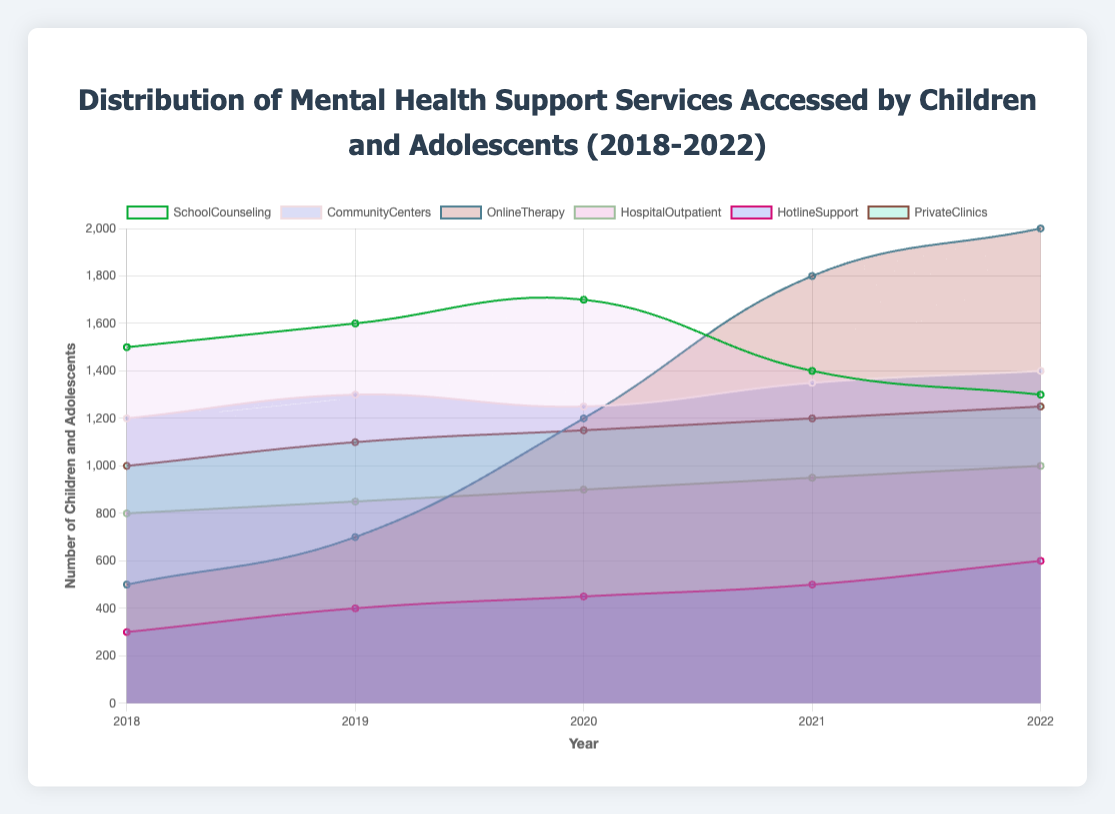What service had the highest access in 2022? The figure shows the values for each service in 2022. The tallest section for that year indicates the service with the highest access.
Answer: OnlineTherapy Which service showed a consistent increase over the five years? Observing the trend lines for each service, we see that OnlineTherapy consistently rises from 2018 to 2022.
Answer: OnlineTherapy How does the trend for School Counseling from 2018 to 2022 compare to Community Centers? From 2018 to 2022, School Counseling initially increases but then decreases, while Community Centers show a gradual increase.
Answer: SchoolCounseling drops while CommunityCenters rises What is the total number of children and adolescents accessing Hospital Outpatient services over 5 years? Summing the given values for Hospital Outpatient (800 + 850 + 900 + 950 + 1000) results in the total access over 5 years.
Answer: 4500 Which year had the highest total number of children accessing all services combined? To find the year with the highest total, sum the values for all services for each year and compare the sums. Summing the values for each year: 2018: 5300; 2019: 5950; 2020: 6650; 2021: 7250; 2022: 7550. So, 2022 has the highest total.
Answer: 2022 Which two services had similar access numbers in 2019? By comparing the values for each service in 2019, SchoolCounseling (1600) and CommunityCenters (1300) shows a close similarity. Alternatively, PrivateClinics and CommunityCenters were closer with 1100 and 1300 respectively.
Answer: PrivateClinics and CommunityCenters What is the difference in total access between School Counseling and Online Therapy over the five years? Summing the values for School Counseling (1500 + 1600 + 1700 + 1400 + 1300 = 7500) and Online Therapy (500 + 700 + 1200 + 1800 + 2000 = 6200), then subtracting, we get 7500 - 6200.
Answer: 1300 Which service had the steepest increase from 2019 to 2021? By comparing the slope of each service's line from 2019 to 2021, OnlineTherapy had the steepest increase from 700 to 1800.
Answer: OnlineTherapy Did Hotline Support ever surpass Private Clinics in access numbers in any year? By comparing Hotline Support's and Private Clinic's values year by year, we see that Hotline Support never surpassed Private Clinics in any year.
Answer: No 